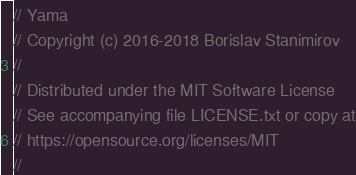<code> <loc_0><loc_0><loc_500><loc_500><_C++_>// Yama
// Copyright (c) 2016-2018 Borislav Stanimirov
//
// Distributed under the MIT Software License
// See accompanying file LICENSE.txt or copy at
// https://opensource.org/licenses/MIT
//</code> 